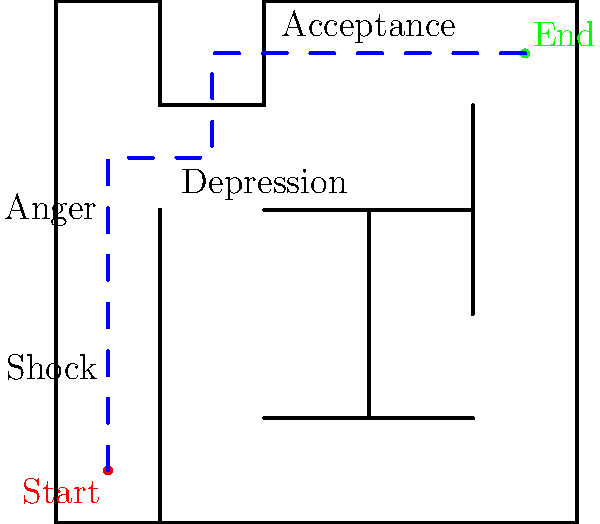In this maze representing the journey of grief and recovery, find the shortest path from the start (red dot) to the end (green dot). Each step in the maze symbolizes a stage in the grieving process. What is the minimum number of steps required to reach acceptance? To solve this maze and find the shortest path, we'll follow these steps:

1. Start at the red dot (0.5, 0.5), representing the initial shock of loss.
2. Move upward to (0.5, 3.5), passing through the "Shock" and "Anger" stages.
3. Turn right and move to (1.5, 3.5), entering the "Depression" stage.
4. Move up to (1.5, 4.5), progressing through depression.
5. Turn right and move to (4.5, 4.5), reaching the "Acceptance" stage at the green dot.

Counting these movements:
1. (0.5, 0.5) to (0.5, 3.5): 3 steps
2. (0.5, 3.5) to (1.5, 3.5): 1 step
3. (1.5, 3.5) to (1.5, 4.5): 1 step
4. (1.5, 4.5) to (4.5, 4.5): 3 steps

The total number of steps is 3 + 1 + 1 + 3 = 8.

This path represents the journey through grief, from the initial shock, through anger and depression, to finally reaching acceptance. The maze's structure shows that grief is not a straight path, but one with turns and occasionally feeling "stuck" before moving forward.
Answer: 8 steps 